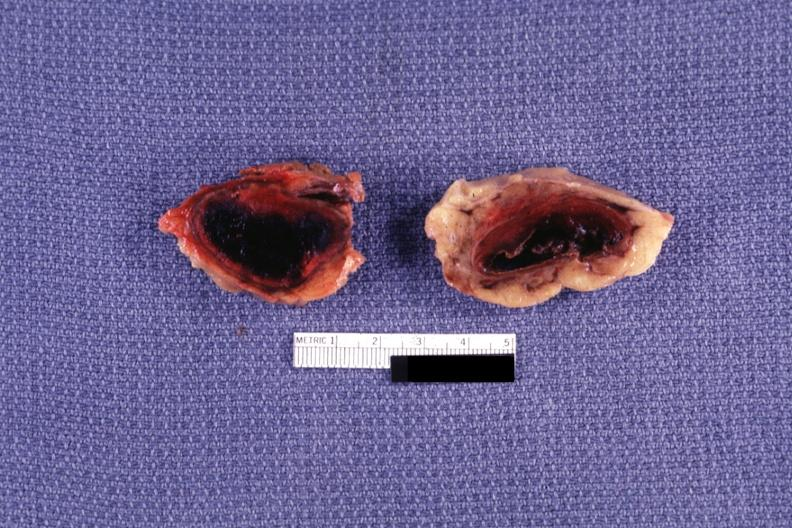what does this image show?
Answer the question using a single word or phrase. Sectioned glands with obvious hemorrhage 